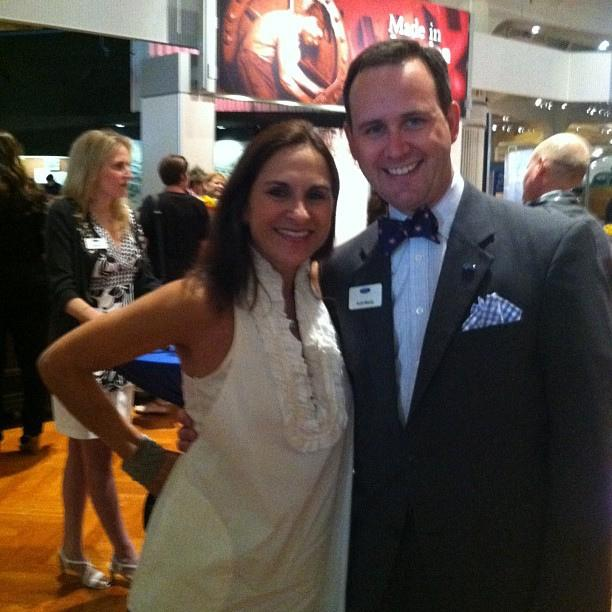At which event do these people pose? party 